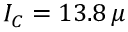Convert formula to latex. <formula><loc_0><loc_0><loc_500><loc_500>I _ { C } = 1 3 . 8 \, \mu</formula> 